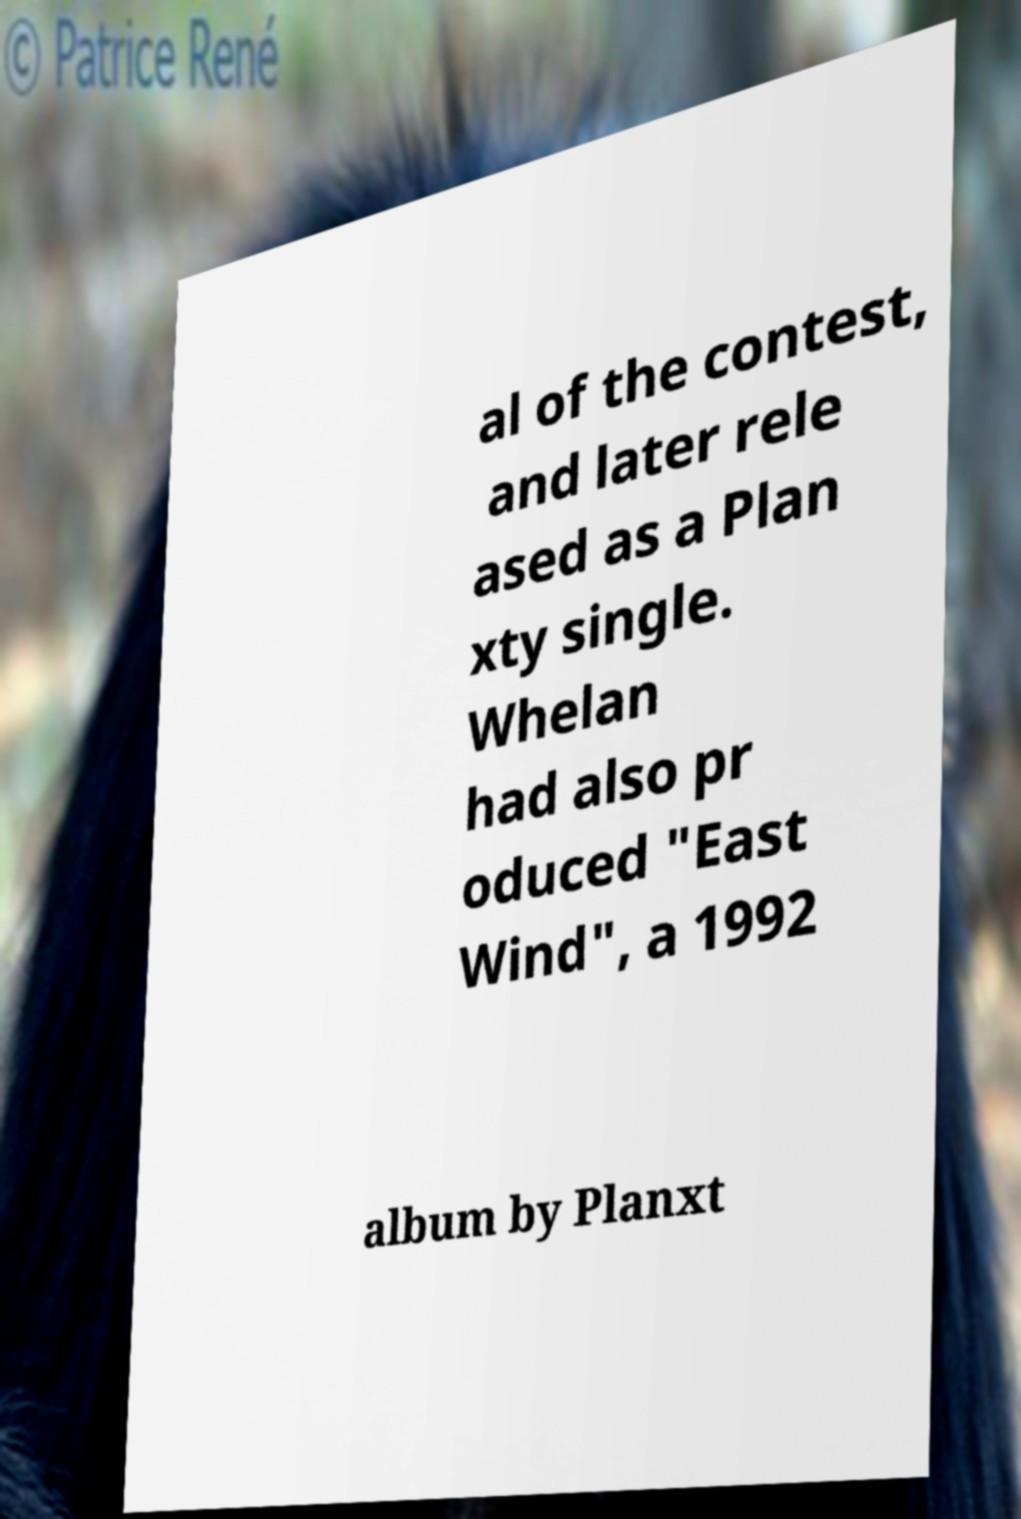Can you accurately transcribe the text from the provided image for me? al of the contest, and later rele ased as a Plan xty single. Whelan had also pr oduced "East Wind", a 1992 album by Planxt 